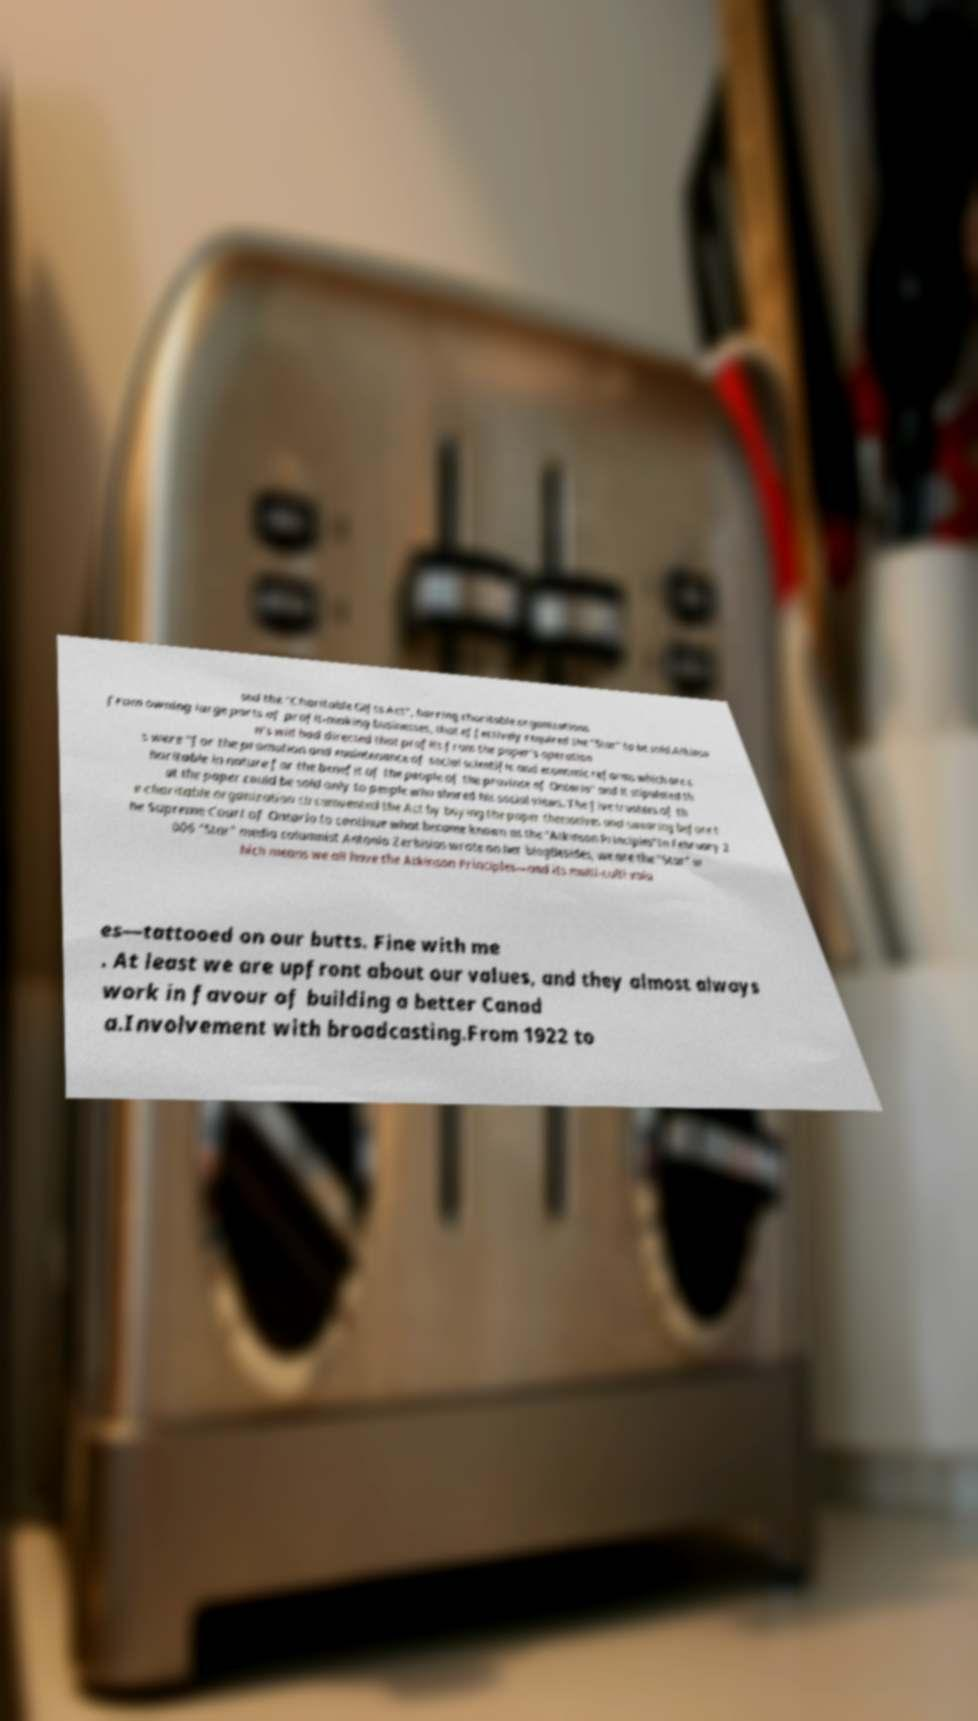What messages or text are displayed in this image? I need them in a readable, typed format. sed the "Charitable Gifts Act", barring charitable organizations from owning large parts of profit-making businesses, that effectively required the "Star" to be sold.Atkinso n's will had directed that profits from the paper's operation s were "for the promotion and maintenance of social scientific and economic reforms which are c haritable in nature for the benefit of the people of the province of Ontario" and it stipulated th at the paper could be sold only to people who shared his social views. The five trustees of th e charitable organization circumvented the Act by buying the paper themselves and swearing before t he Supreme Court of Ontario to continue what became known as the "Atkinson Principles"In February 2 006 "Star" media columnist Antonia Zerbisias wrote on her blogBesides, we are the "Star" w hich means we all have the Atkinson Principles—and its multi-culti valu es—tattooed on our butts. Fine with me . At least we are upfront about our values, and they almost always work in favour of building a better Canad a.Involvement with broadcasting.From 1922 to 